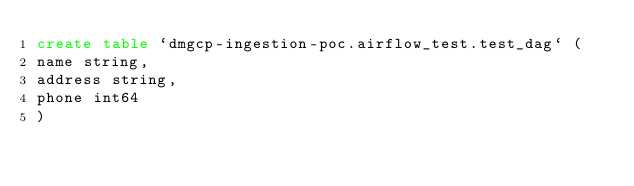Convert code to text. <code><loc_0><loc_0><loc_500><loc_500><_SQL_>create table `dmgcp-ingestion-poc.airflow_test.test_dag` (
name string,
address string,
phone int64
)</code> 